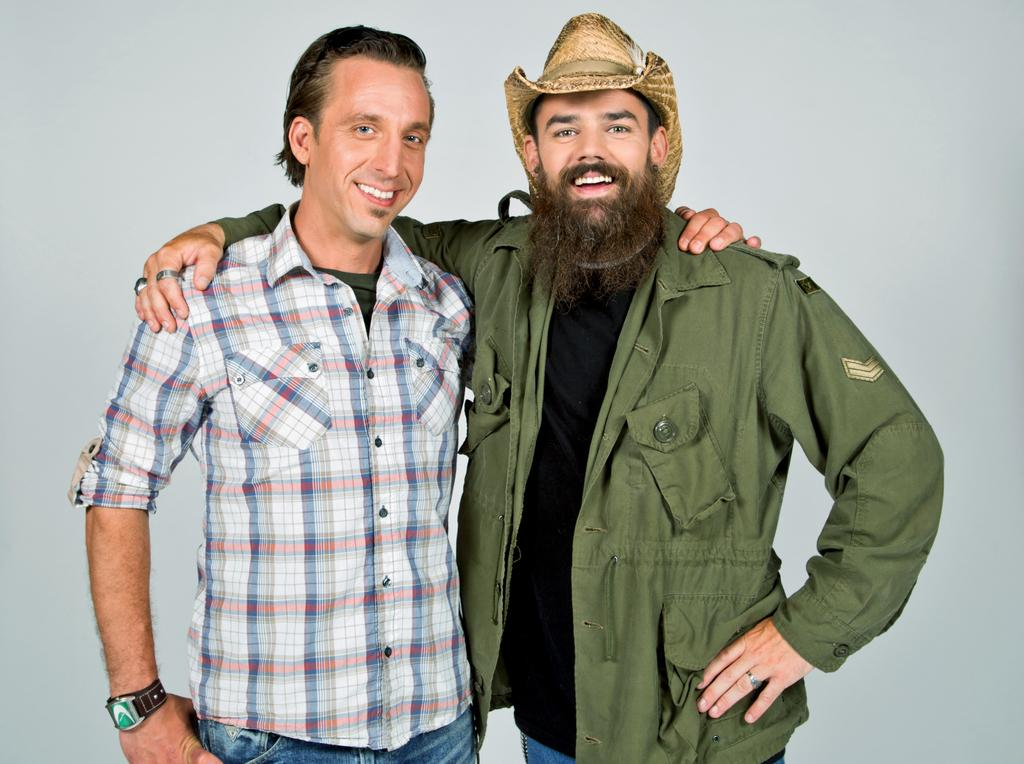How many people are in the image? There is a group of persons in the image. What are the persons in the image doing? The persons are standing. What is the facial expression of the persons in the image? The persons are smiling. What type of quiver can be seen in the hands of the persons in the image? There is no quiver present in the image; the persons are not holding any such object. 